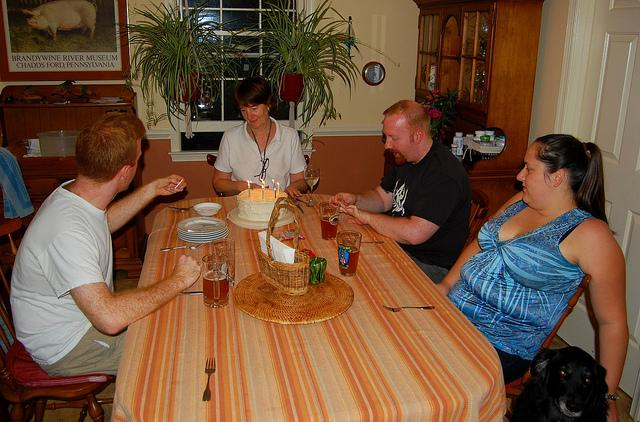Why are there candles in the cake in front of the woman?

Choices:
A) for light
B) her graduation
C) her birthday
D) decoration her birthday 